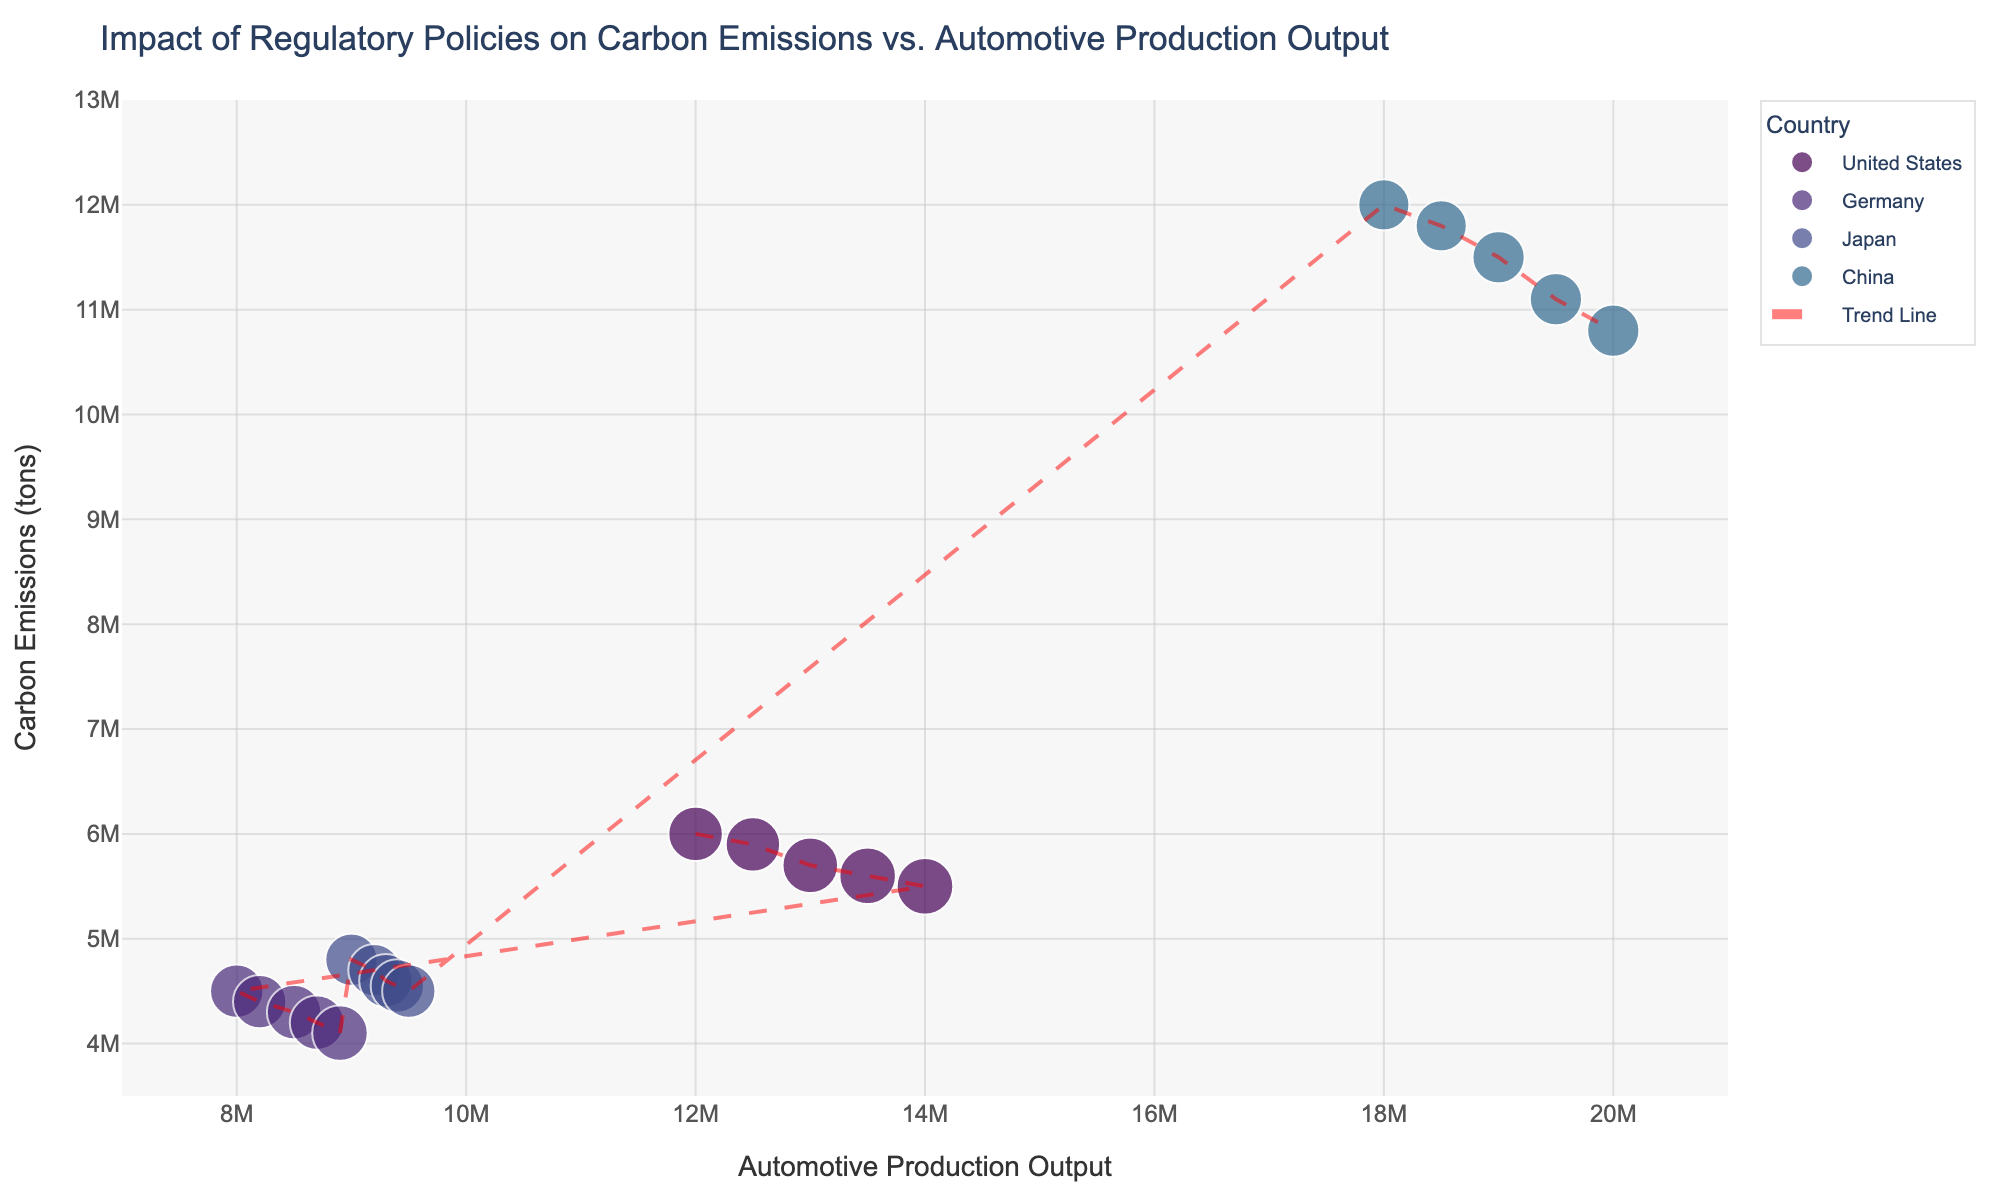What's the title of the plot? The title is usually displayed at the top of the plot. In this figure, it states "Impact of Regulatory Policies on Carbon Emissions vs. Automotive Production Output".
Answer: Impact of Regulatory Policies on Carbon Emissions vs. Automotive Production Output What does the x-axis represent? To understand what the x-axis represents, look at the label directly below the horizontal axis. It is labeled "Automotive Production Output".
Answer: Automotive Production Output What's the highest mileage emissions requirement among the data points? To find this, observe the sizes of the data points since size correlates with "Mileage Emissions Requirement". The largest points correspond to the highest mileage emissions requirement. In this case, the maximum value is 27.
Answer: 27 Which country shows the highest automotive production output in 2019? Look for the data points corresponding to the year 2019 and identify the one with the highest x-axis value. The point for China in 2019 has the highest automotive production output of 20,000,000.
Answer: China Which country has the trend showing a decrease in Carbon Emissions despite an increase in Automotive Production Output? By examining the trend lines and scatter points for each country, one can see that the United States and Germany show a general decrease in carbon emissions as automotive production output increases.
Answer: United States, Germany What is the color associated with Germany? Check the legend in the figure that maps each country to a specific color. Germany is represented by a distinct color indicated in the legend.
Answer: The legend specifies the color, assuming it’s listed, the answer could be: about a greenish hue (based on Viridis color scale) What is the trend in Carbon Emissions for Japan from 2015 to 2019? Look at the points associated with Japan and observe the y-axis values over the years. Japan shows a decreasing trend in carbon emissions, going from higher values in 2015 to lower values in 2019 as production output increases slightly.
Answer: Decreasing How do the carbon emissions in China compare with those in the United States in 2017? Find the data points for China and the United States in 2017, then compare their y-axis values. The carbon emissions in 2017 are higher for China (11,500,000) than for the United States (5,700,000).
Answer: China's emissions are higher What would be the expected carbon emissions for an automotive production output of 15,000,000 based on the trend line? Locate the trend line on the graph and see the corresponding y-axis value for an x-axis value of 15,000,000. This would provide an estimated carbon emissions value. According to trend line positioning, carbon emissions would be around 6,000,000 to 7,000,000 tons.
Answer: Approximately 6,000,000 to 7,000,000 tons 